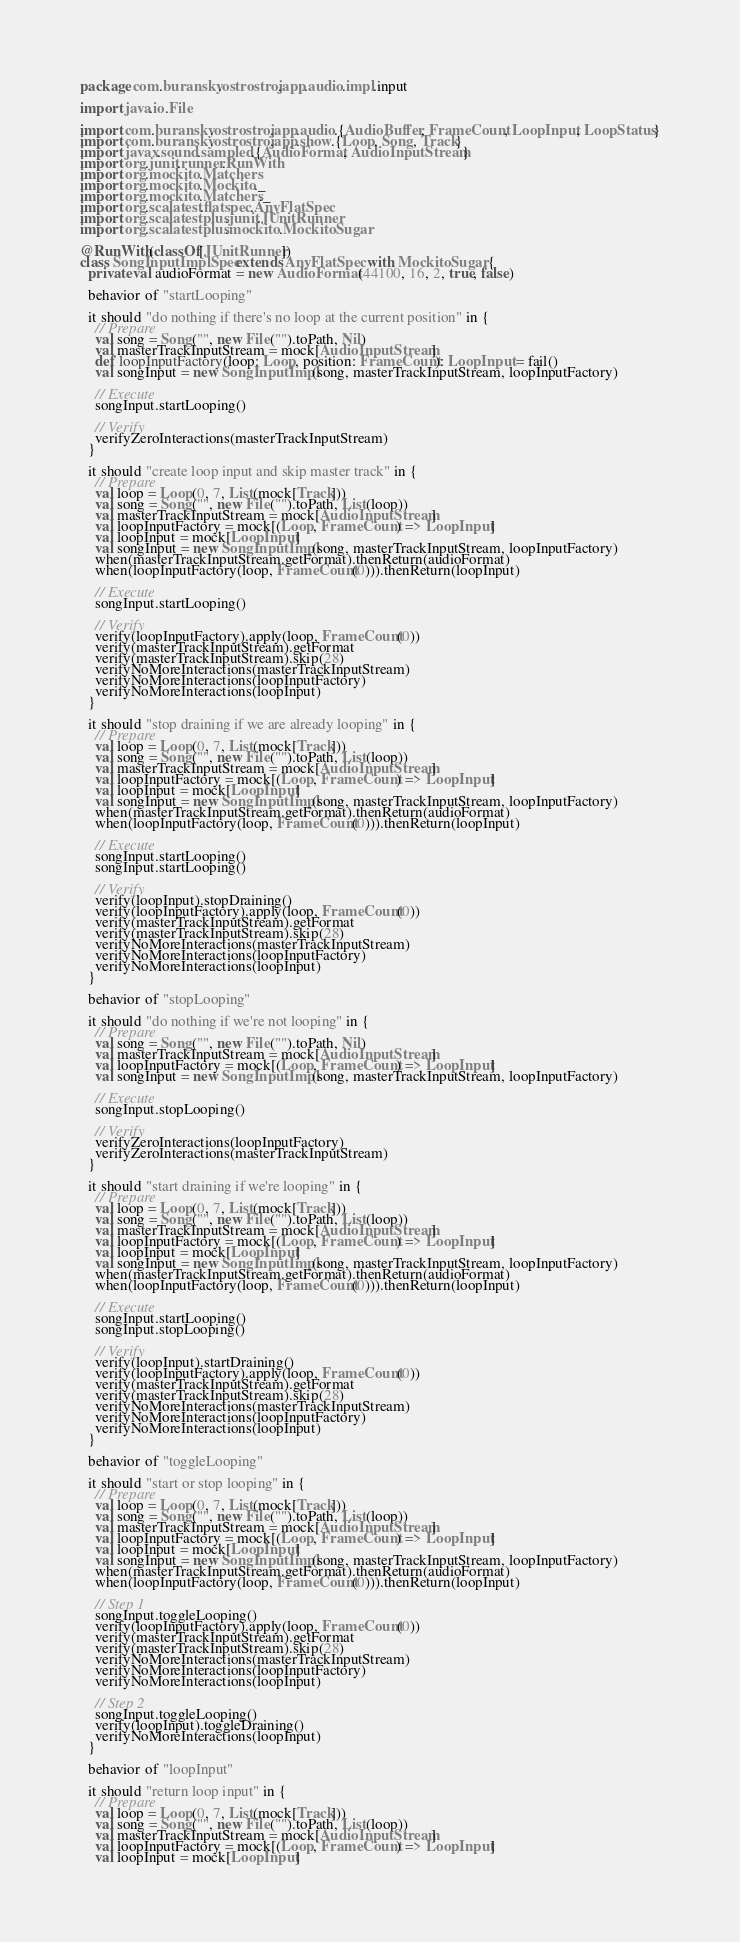Convert code to text. <code><loc_0><loc_0><loc_500><loc_500><_Scala_>package com.buransky.ostrostroj.app.audio.impl.input

import java.io.File

import com.buransky.ostrostroj.app.audio.{AudioBuffer, FrameCount, LoopInput, LoopStatus}
import com.buransky.ostrostroj.app.show.{Loop, Song, Track}
import javax.sound.sampled.{AudioFormat, AudioInputStream}
import org.junit.runner.RunWith
import org.mockito.Matchers
import org.mockito.Mockito._
import org.mockito.Matchers._
import org.scalatest.flatspec.AnyFlatSpec
import org.scalatestplus.junit.JUnitRunner
import org.scalatestplus.mockito.MockitoSugar

@RunWith(classOf[JUnitRunner])
class SongInputImplSpec extends AnyFlatSpec with MockitoSugar {
  private val audioFormat = new AudioFormat(44100, 16, 2, true, false)

  behavior of "startLooping"

  it should "do nothing if there's no loop at the current position" in {
    // Prepare
    val song = Song("", new File("").toPath, Nil)
    val masterTrackInputStream = mock[AudioInputStream]
    def loopInputFactory(loop: Loop, position: FrameCount): LoopInput = fail()
    val songInput = new SongInputImpl(song, masterTrackInputStream, loopInputFactory)

    // Execute
    songInput.startLooping()

    // Verify
    verifyZeroInteractions(masterTrackInputStream)
  }

  it should "create loop input and skip master track" in {
    // Prepare
    val loop = Loop(0, 7, List(mock[Track]))
    val song = Song("", new File("").toPath, List(loop))
    val masterTrackInputStream = mock[AudioInputStream]
    val loopInputFactory = mock[(Loop, FrameCount) => LoopInput]
    val loopInput = mock[LoopInput]
    val songInput = new SongInputImpl(song, masterTrackInputStream, loopInputFactory)
    when(masterTrackInputStream.getFormat).thenReturn(audioFormat)
    when(loopInputFactory(loop, FrameCount(0))).thenReturn(loopInput)

    // Execute
    songInput.startLooping()

    // Verify
    verify(loopInputFactory).apply(loop, FrameCount(0))
    verify(masterTrackInputStream).getFormat
    verify(masterTrackInputStream).skip(28)
    verifyNoMoreInteractions(masterTrackInputStream)
    verifyNoMoreInteractions(loopInputFactory)
    verifyNoMoreInteractions(loopInput)
  }

  it should "stop draining if we are already looping" in {
    // Prepare
    val loop = Loop(0, 7, List(mock[Track]))
    val song = Song("", new File("").toPath, List(loop))
    val masterTrackInputStream = mock[AudioInputStream]
    val loopInputFactory = mock[(Loop, FrameCount) => LoopInput]
    val loopInput = mock[LoopInput]
    val songInput = new SongInputImpl(song, masterTrackInputStream, loopInputFactory)
    when(masterTrackInputStream.getFormat).thenReturn(audioFormat)
    when(loopInputFactory(loop, FrameCount(0))).thenReturn(loopInput)

    // Execute
    songInput.startLooping()
    songInput.startLooping()

    // Verify
    verify(loopInput).stopDraining()
    verify(loopInputFactory).apply(loop, FrameCount(0))
    verify(masterTrackInputStream).getFormat
    verify(masterTrackInputStream).skip(28)
    verifyNoMoreInteractions(masterTrackInputStream)
    verifyNoMoreInteractions(loopInputFactory)
    verifyNoMoreInteractions(loopInput)
  }

  behavior of "stopLooping"

  it should "do nothing if we're not looping" in {
    // Prepare
    val song = Song("", new File("").toPath, Nil)
    val masterTrackInputStream = mock[AudioInputStream]
    val loopInputFactory = mock[(Loop, FrameCount) => LoopInput]
    val songInput = new SongInputImpl(song, masterTrackInputStream, loopInputFactory)

    // Execute
    songInput.stopLooping()

    // Verify
    verifyZeroInteractions(loopInputFactory)
    verifyZeroInteractions(masterTrackInputStream)
  }

  it should "start draining if we're looping" in {
    // Prepare
    val loop = Loop(0, 7, List(mock[Track]))
    val song = Song("", new File("").toPath, List(loop))
    val masterTrackInputStream = mock[AudioInputStream]
    val loopInputFactory = mock[(Loop, FrameCount) => LoopInput]
    val loopInput = mock[LoopInput]
    val songInput = new SongInputImpl(song, masterTrackInputStream, loopInputFactory)
    when(masterTrackInputStream.getFormat).thenReturn(audioFormat)
    when(loopInputFactory(loop, FrameCount(0))).thenReturn(loopInput)

    // Execute
    songInput.startLooping()
    songInput.stopLooping()

    // Verify
    verify(loopInput).startDraining()
    verify(loopInputFactory).apply(loop, FrameCount(0))
    verify(masterTrackInputStream).getFormat
    verify(masterTrackInputStream).skip(28)
    verifyNoMoreInteractions(masterTrackInputStream)
    verifyNoMoreInteractions(loopInputFactory)
    verifyNoMoreInteractions(loopInput)
  }

  behavior of "toggleLooping"

  it should "start or stop looping" in {
    // Prepare
    val loop = Loop(0, 7, List(mock[Track]))
    val song = Song("", new File("").toPath, List(loop))
    val masterTrackInputStream = mock[AudioInputStream]
    val loopInputFactory = mock[(Loop, FrameCount) => LoopInput]
    val loopInput = mock[LoopInput]
    val songInput = new SongInputImpl(song, masterTrackInputStream, loopInputFactory)
    when(masterTrackInputStream.getFormat).thenReturn(audioFormat)
    when(loopInputFactory(loop, FrameCount(0))).thenReturn(loopInput)

    // Step 1
    songInput.toggleLooping()
    verify(loopInputFactory).apply(loop, FrameCount(0))
    verify(masterTrackInputStream).getFormat
    verify(masterTrackInputStream).skip(28)
    verifyNoMoreInteractions(masterTrackInputStream)
    verifyNoMoreInteractions(loopInputFactory)
    verifyNoMoreInteractions(loopInput)

    // Step 2
    songInput.toggleLooping()
    verify(loopInput).toggleDraining()
    verifyNoMoreInteractions(loopInput)
  }

  behavior of "loopInput"

  it should "return loop input" in {
    // Prepare
    val loop = Loop(0, 7, List(mock[Track]))
    val song = Song("", new File("").toPath, List(loop))
    val masterTrackInputStream = mock[AudioInputStream]
    val loopInputFactory = mock[(Loop, FrameCount) => LoopInput]
    val loopInput = mock[LoopInput]</code> 